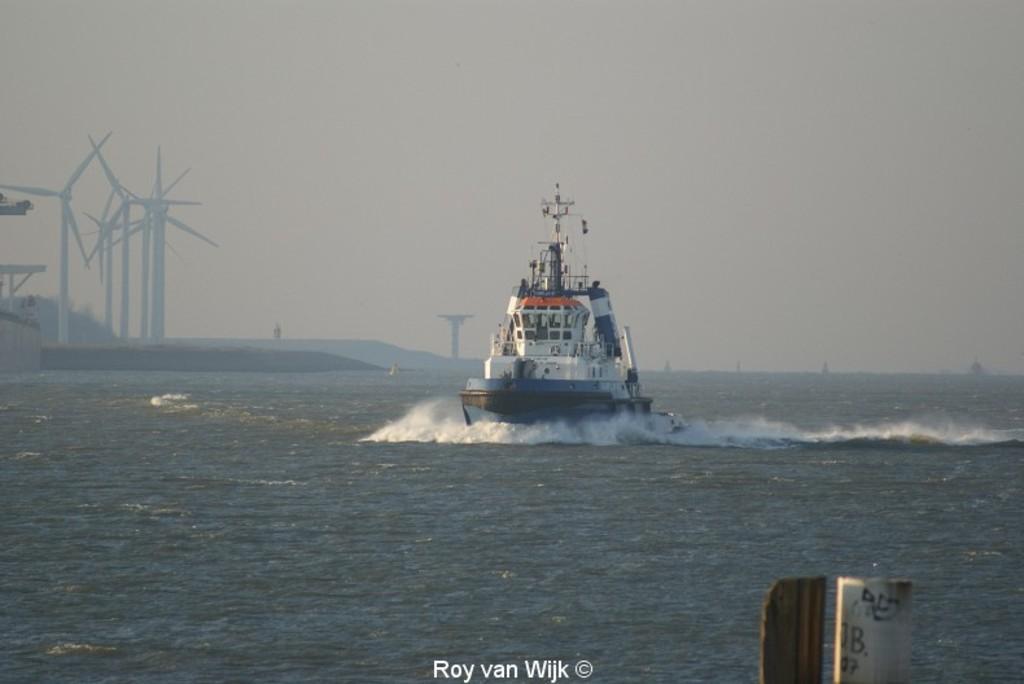Could you give a brief overview of what you see in this image? In this picture I can see e a ship in the water and few windmills on the left side and I can see water and text at the bottom of the picture and I can see cloudy sky. 